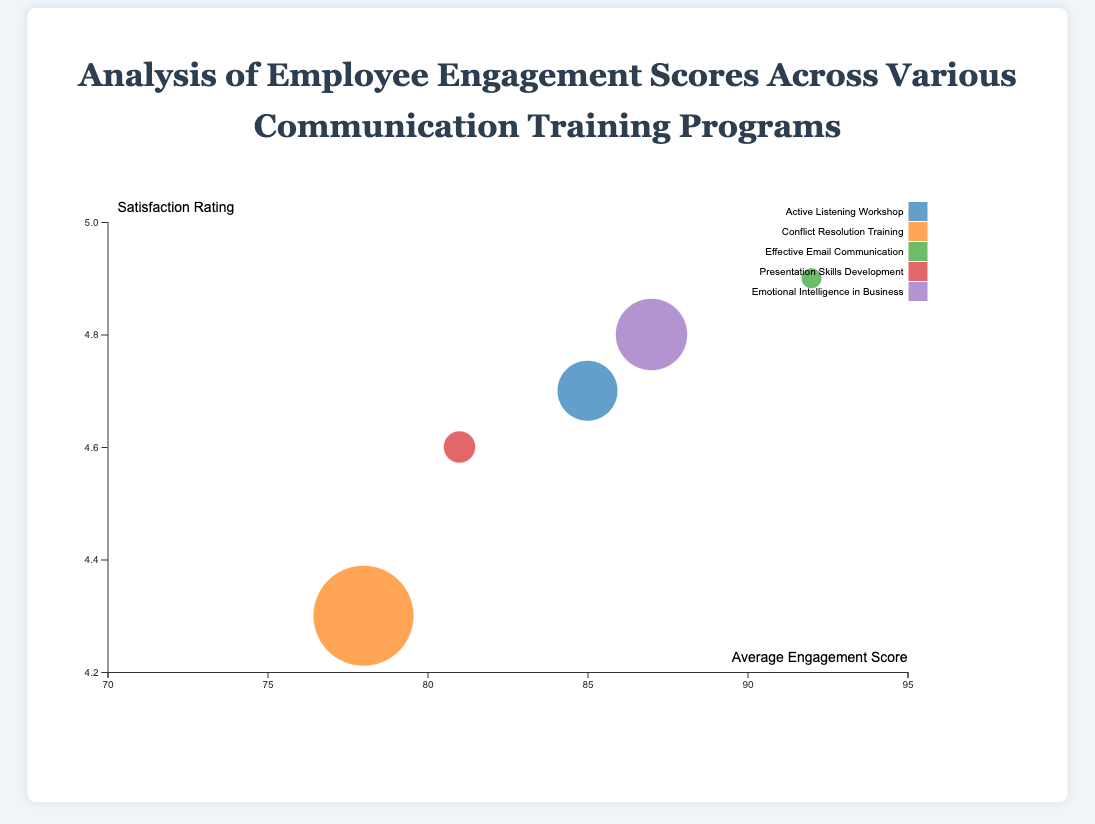What is the title of the chart? The title is written at the top center of the chart. It helps the viewer understand the subject of the chart.
Answer: Analysis of Employee Engagement Scores Across Various Communication Training Programs How many training programs are displayed in the chart? Count the different data points, which are represented as bubbles in the chart. Each bubble corresponds to a training program.
Answer: 5 Which training program has the highest average engagement score? Look at the x-axis, which represents the average engagement score, and identify the bubble farthest to the right.
Answer: Effective Email Communication What color is used to represent the "Emotional Intelligence in Business" training program? Identify the specific bubble for "Emotional Intelligence in Business" either through legend or hover in the tooltip. Check the color assigned to it.
Answer: Color from d3.schemeCategory10, typically a shade in the 10-color qualitative scale Which training program has the highest satisfaction rating? Look at the y-axis, which represents satisfaction rating, and find the bubble positioned highest on this axis.
Answer: Effective Email Communication Which training program has the largest number of employees participating? The size of the bubbles represents the number of employees. Find the largest bubble.
Answer: Conflict Resolution Training Compare the average engagement scores between "Active Listening Workshop" and "Presentation Skills Development." Which one is higher? Note the positions of these two bubbles on the x-axis. The one farther to the right has a higher average engagement score.
Answer: Active Listening Workshop (85 vs. 81) Which training programs have an average engagement score above 85? Identify the bubbles positioned to the right of the 85 mark on the x-axis.
Answer: Active Listening Workshop, Effective Email Communication, Emotional Intelligence in Business What is the average engagement score for the "Conflict Resolution Training"? Locate the "Conflict Resolution Training" bubble on the x-axis, which shows the average engagement score.
Answer: 78 Is there any training program with a satisfaction rating below 4.5? If so, which one? Check the y-axis for values below 4.5 and identify the corresponding bubble.
Answer: Conflict Resolution Training (4.3) 